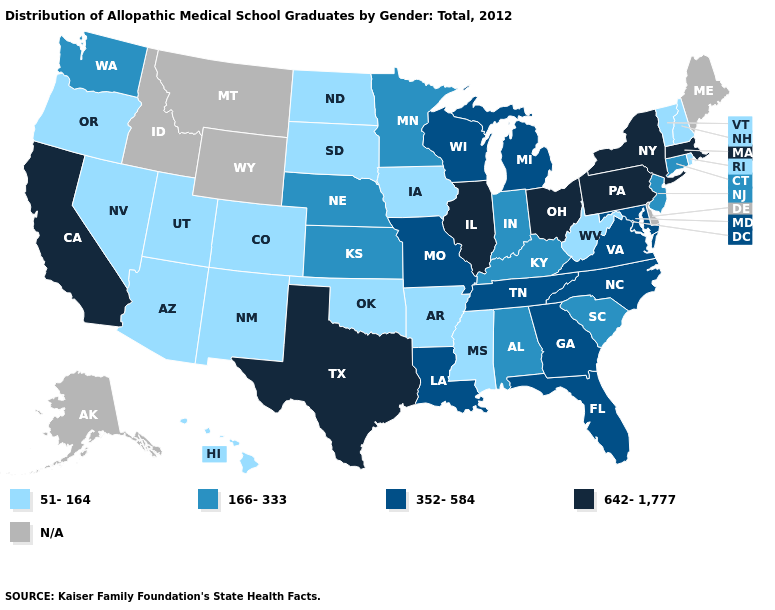Name the states that have a value in the range 166-333?
Be succinct. Alabama, Connecticut, Indiana, Kansas, Kentucky, Minnesota, Nebraska, New Jersey, South Carolina, Washington. What is the value of California?
Concise answer only. 642-1,777. Does the map have missing data?
Give a very brief answer. Yes. What is the highest value in the USA?
Keep it brief. 642-1,777. Which states have the highest value in the USA?
Quick response, please. California, Illinois, Massachusetts, New York, Ohio, Pennsylvania, Texas. Among the states that border Illinois , does Wisconsin have the highest value?
Short answer required. Yes. What is the value of Washington?
Short answer required. 166-333. What is the highest value in states that border Louisiana?
Answer briefly. 642-1,777. Name the states that have a value in the range 352-584?
Answer briefly. Florida, Georgia, Louisiana, Maryland, Michigan, Missouri, North Carolina, Tennessee, Virginia, Wisconsin. What is the value of Utah?
Be succinct. 51-164. Does Oklahoma have the lowest value in the USA?
Give a very brief answer. Yes. Name the states that have a value in the range N/A?
Quick response, please. Alaska, Delaware, Idaho, Maine, Montana, Wyoming. 